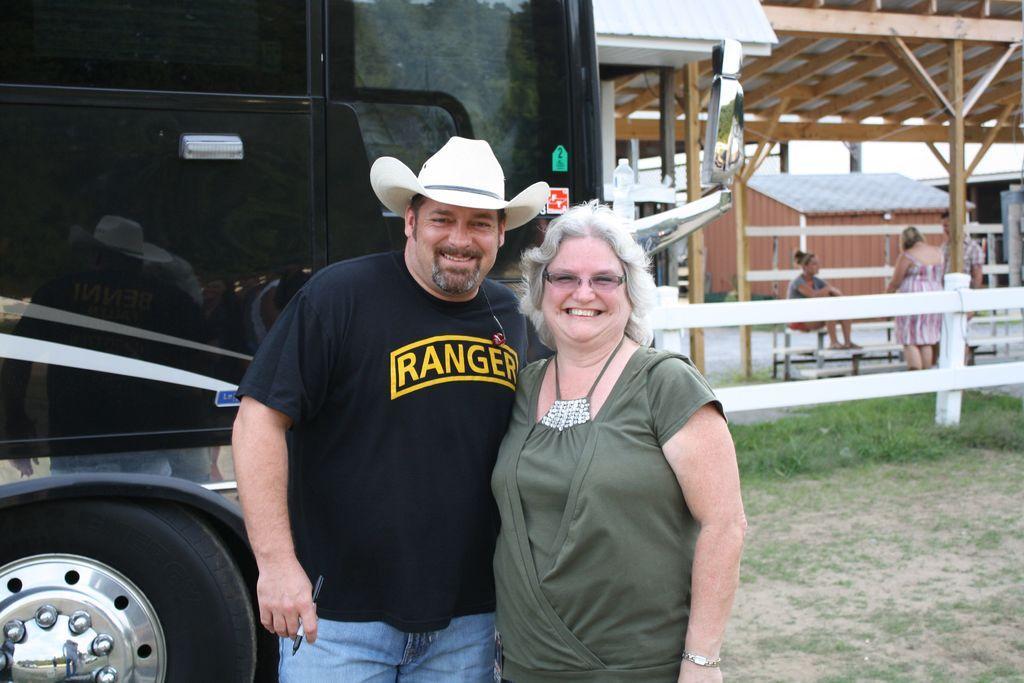Describe this image in one or two sentences. In this image in the front there are persons standing and smiling. In the center there is a vehicle and there's grass on the ground. In the background there are persons sitting and standing and there is a wooden shelter and there is a fence. 